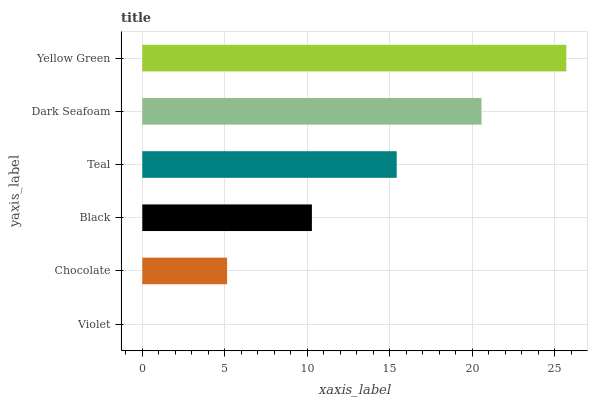Is Violet the minimum?
Answer yes or no. Yes. Is Yellow Green the maximum?
Answer yes or no. Yes. Is Chocolate the minimum?
Answer yes or no. No. Is Chocolate the maximum?
Answer yes or no. No. Is Chocolate greater than Violet?
Answer yes or no. Yes. Is Violet less than Chocolate?
Answer yes or no. Yes. Is Violet greater than Chocolate?
Answer yes or no. No. Is Chocolate less than Violet?
Answer yes or no. No. Is Teal the high median?
Answer yes or no. Yes. Is Black the low median?
Answer yes or no. Yes. Is Yellow Green the high median?
Answer yes or no. No. Is Teal the low median?
Answer yes or no. No. 